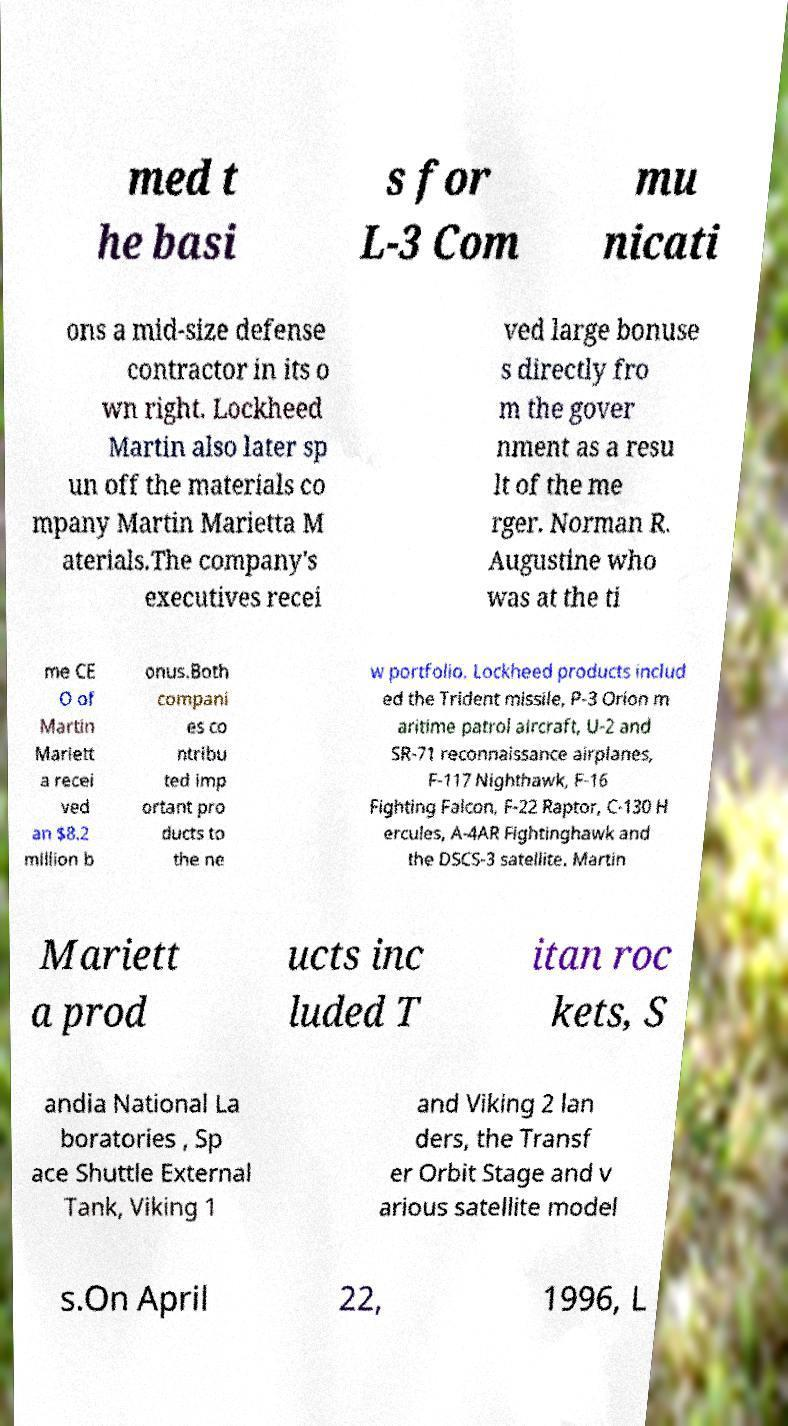There's text embedded in this image that I need extracted. Can you transcribe it verbatim? med t he basi s for L-3 Com mu nicati ons a mid-size defense contractor in its o wn right. Lockheed Martin also later sp un off the materials co mpany Martin Marietta M aterials.The company's executives recei ved large bonuse s directly fro m the gover nment as a resu lt of the me rger. Norman R. Augustine who was at the ti me CE O of Martin Mariett a recei ved an $8.2 million b onus.Both compani es co ntribu ted imp ortant pro ducts to the ne w portfolio. Lockheed products includ ed the Trident missile, P-3 Orion m aritime patrol aircraft, U-2 and SR-71 reconnaissance airplanes, F-117 Nighthawk, F-16 Fighting Falcon, F-22 Raptor, C-130 H ercules, A-4AR Fightinghawk and the DSCS-3 satellite. Martin Mariett a prod ucts inc luded T itan roc kets, S andia National La boratories , Sp ace Shuttle External Tank, Viking 1 and Viking 2 lan ders, the Transf er Orbit Stage and v arious satellite model s.On April 22, 1996, L 